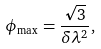<formula> <loc_0><loc_0><loc_500><loc_500>\phi _ { \max } = \frac { \sqrt { 3 } } { \delta \lambda ^ { 2 } } ,</formula> 